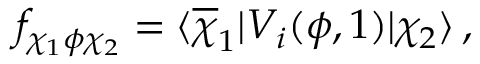Convert formula to latex. <formula><loc_0><loc_0><loc_500><loc_500>f _ { \chi _ { 1 } \phi \chi _ { 2 } } = \langle \overline { \chi } _ { 1 } | V _ { i } ( \phi , 1 ) | \chi _ { 2 } \rangle \, ,</formula> 